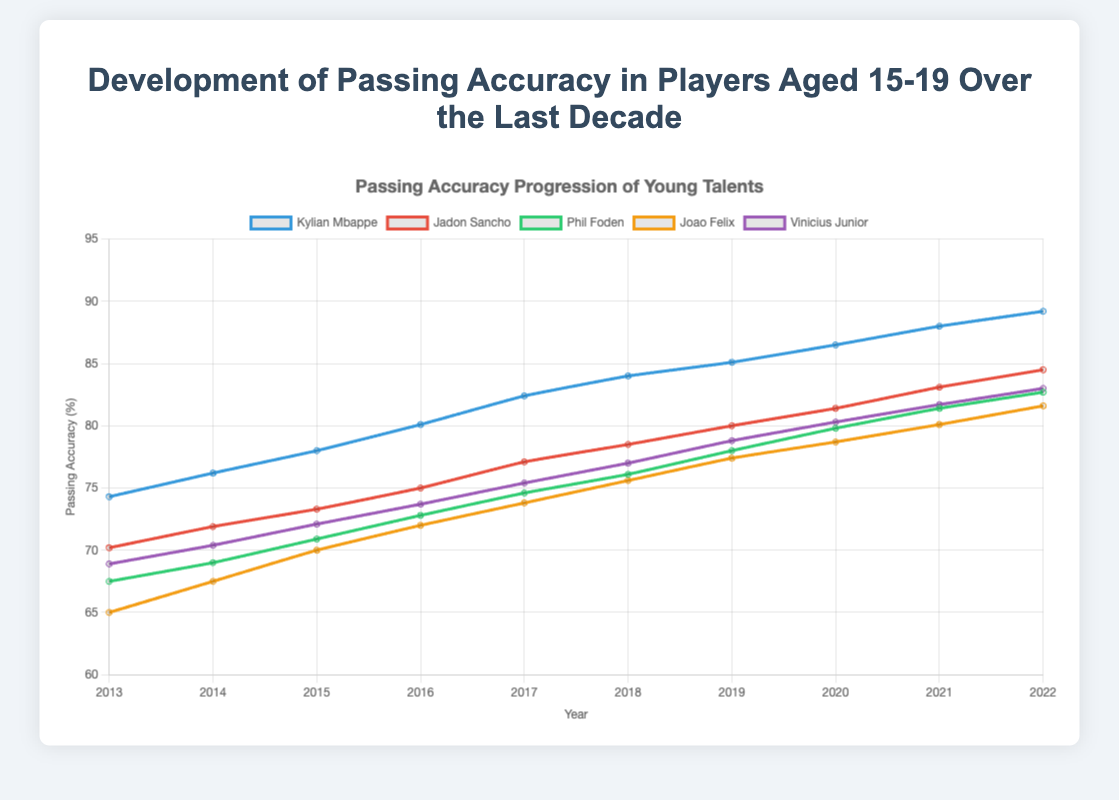Which player showed the highest increase in passing accuracy from 2013 to 2022? To determine the highest increase, we subtract the passing accuracy in 2013 from the passing accuracy in 2022 for each player. Mbappe: 89.2 - 74.3 = 14.9, Sancho: 84.5 - 70.2 = 14.3, Foden: 82.7 - 67.5 = 15.2, Felix: 81.6 - 65.0 = 16.6, Vinicius: 83.0 - 68.9 = 14.1. Joao Felix shows the highest increase.
Answer: Joao Felix Which year did Vinicius Junior surpass a passing accuracy of 80%? Locate the data point where Vinicius's passing accuracy just exceeds 80%. This occurs in the year 2020 as he has 80.3%.
Answer: 2020 Who had the lowest passing accuracy in 2013? Compare the 2013 passing accuracies of all players: Mbappe (74.3), Sancho (70.2), Foden (67.5), Felix (65.0), and Vinicius (68.9). Joao Felix had the lowest passing accuracy in 2013.
Answer: Joao Felix Comparing the trend lines, which player had a consistently steeper increase in passing accuracy each consecutive year? By visually checking the slope of each player's line, which represents the rate of increase, Mbappe shows a consistent, steeper increase every year than the others.
Answer: Kylian Mbappe What is the average passing accuracy of Phil Foden over the decade? Add the passing accuracy of Foden from 2013 to 2022 and divide by the number of years. (67.5 + 69.0 + 70.9 + 72.8 + 74.6 + 76.1 + 78.0 + 79.8 + 81.4 + 82.7) / 10 = 75.28
Answer: 75.28 In which year did Kylian Mbappe first achieve more than 80% passing accuracy? Observe the data for Kylian Mbappe; he first exceeded 80% in 2016 with an accuracy of 80.1%.
Answer: 2016 Which two players had their passing accuracy most similar in 2021, and what were their accuracies? Compare the 2021 values: Mbappe (88.0), Sancho (83.1), Foden (81.4), Felix (80.1), Vinicius (81.7). Foden (81.4) and Vinicius (81.7) had the most similar accuracies.
Answer: Phil Foden and Vinicius Junior, 81.4 and 81.7 How does the passing accuracy change for Jadon Sancho between 2018 and 2019? Calculate the difference in Sancho's passing accuracy between 2018 and 2019. 80.0 - 78.5 = 1.5 increase
Answer: Increased by 1.5 Which player had a passing accuracy closest to 90% by 2022? By checking each player's 2022 data, Mbappe (89.2), Sancho (84.5), Foden (82.7), Felix (81.6), Vinicius (83.0). Kylian Mbappe is closest to 90%.
Answer: Kylian Mbappe 